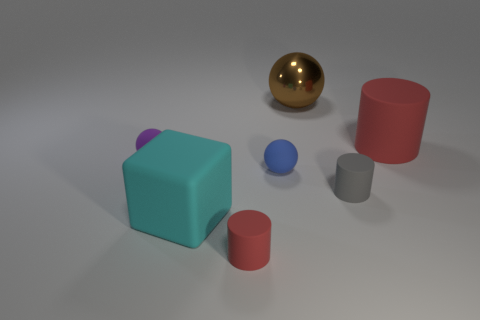How many red cylinders must be subtracted to get 1 red cylinders? 1 Subtract all purple blocks. How many red cylinders are left? 2 Subtract all red matte cylinders. How many cylinders are left? 1 Add 1 blocks. How many objects exist? 8 Subtract all blocks. How many objects are left? 6 Subtract 2 balls. How many balls are left? 1 Subtract all yellow blocks. Subtract all green spheres. How many blocks are left? 1 Subtract all blue rubber objects. Subtract all large cyan cubes. How many objects are left? 5 Add 3 small red rubber cylinders. How many small red rubber cylinders are left? 4 Add 4 big cyan matte cylinders. How many big cyan matte cylinders exist? 4 